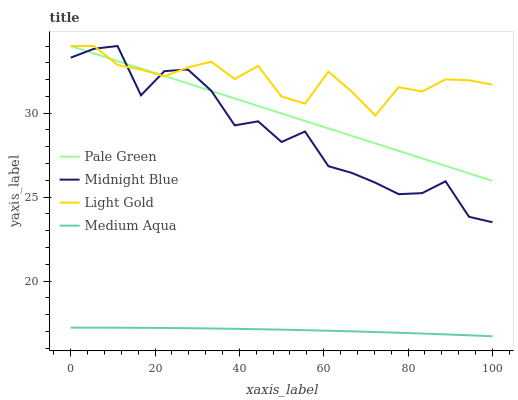Does Medium Aqua have the minimum area under the curve?
Answer yes or no. Yes. Does Light Gold have the maximum area under the curve?
Answer yes or no. Yes. Does Pale Green have the minimum area under the curve?
Answer yes or no. No. Does Pale Green have the maximum area under the curve?
Answer yes or no. No. Is Pale Green the smoothest?
Answer yes or no. Yes. Is Midnight Blue the roughest?
Answer yes or no. Yes. Is Light Gold the smoothest?
Answer yes or no. No. Is Light Gold the roughest?
Answer yes or no. No. Does Medium Aqua have the lowest value?
Answer yes or no. Yes. Does Pale Green have the lowest value?
Answer yes or no. No. Does Midnight Blue have the highest value?
Answer yes or no. Yes. Is Medium Aqua less than Pale Green?
Answer yes or no. Yes. Is Light Gold greater than Medium Aqua?
Answer yes or no. Yes. Does Pale Green intersect Light Gold?
Answer yes or no. Yes. Is Pale Green less than Light Gold?
Answer yes or no. No. Is Pale Green greater than Light Gold?
Answer yes or no. No. Does Medium Aqua intersect Pale Green?
Answer yes or no. No. 